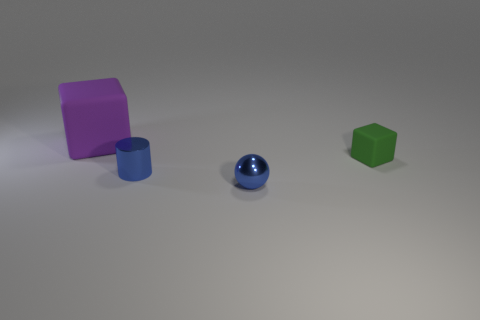What number of other things are there of the same shape as the big rubber object? There is one other object sharing the same cylindrical shape as the large rubber cylinder, which is the smaller blue cylinder. 